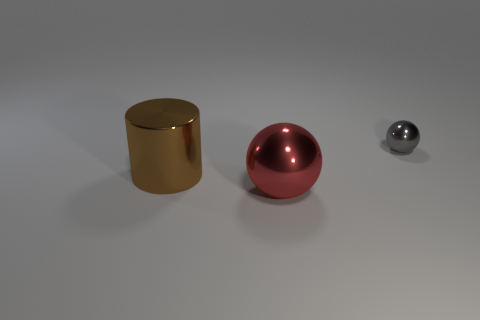There is a big object that is behind the big metal thing that is in front of the large cylinder; what is its shape?
Make the answer very short. Cylinder. What is the shape of the big brown thing that is made of the same material as the gray object?
Make the answer very short. Cylinder. There is a metallic object that is left of the sphere that is on the left side of the small metallic sphere; what size is it?
Provide a succinct answer. Large. There is a gray shiny object; what shape is it?
Make the answer very short. Sphere. How many tiny things are either metal spheres or purple metal objects?
Keep it short and to the point. 1. There is another red object that is the same shape as the tiny metal thing; what size is it?
Make the answer very short. Large. What number of metallic things are both right of the red object and on the left side of the red thing?
Offer a very short reply. 0. Do the gray metal object and the big thing that is on the right side of the cylinder have the same shape?
Offer a terse response. Yes. Is the number of metallic spheres that are behind the red metallic object greater than the number of blue spheres?
Your response must be concise. Yes. Is the number of objects to the right of the tiny shiny sphere less than the number of large metal cubes?
Keep it short and to the point. No. 